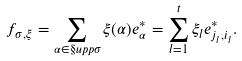Convert formula to latex. <formula><loc_0><loc_0><loc_500><loc_500>f _ { \sigma , \xi } = \sum _ { \alpha \in \S u p p { \sigma } } \xi ( \alpha ) e _ { \alpha } ^ { * } = \sum _ { l = 1 } ^ { t } \xi _ { l } e _ { j _ { l } , i _ { l } } ^ { * } .</formula> 